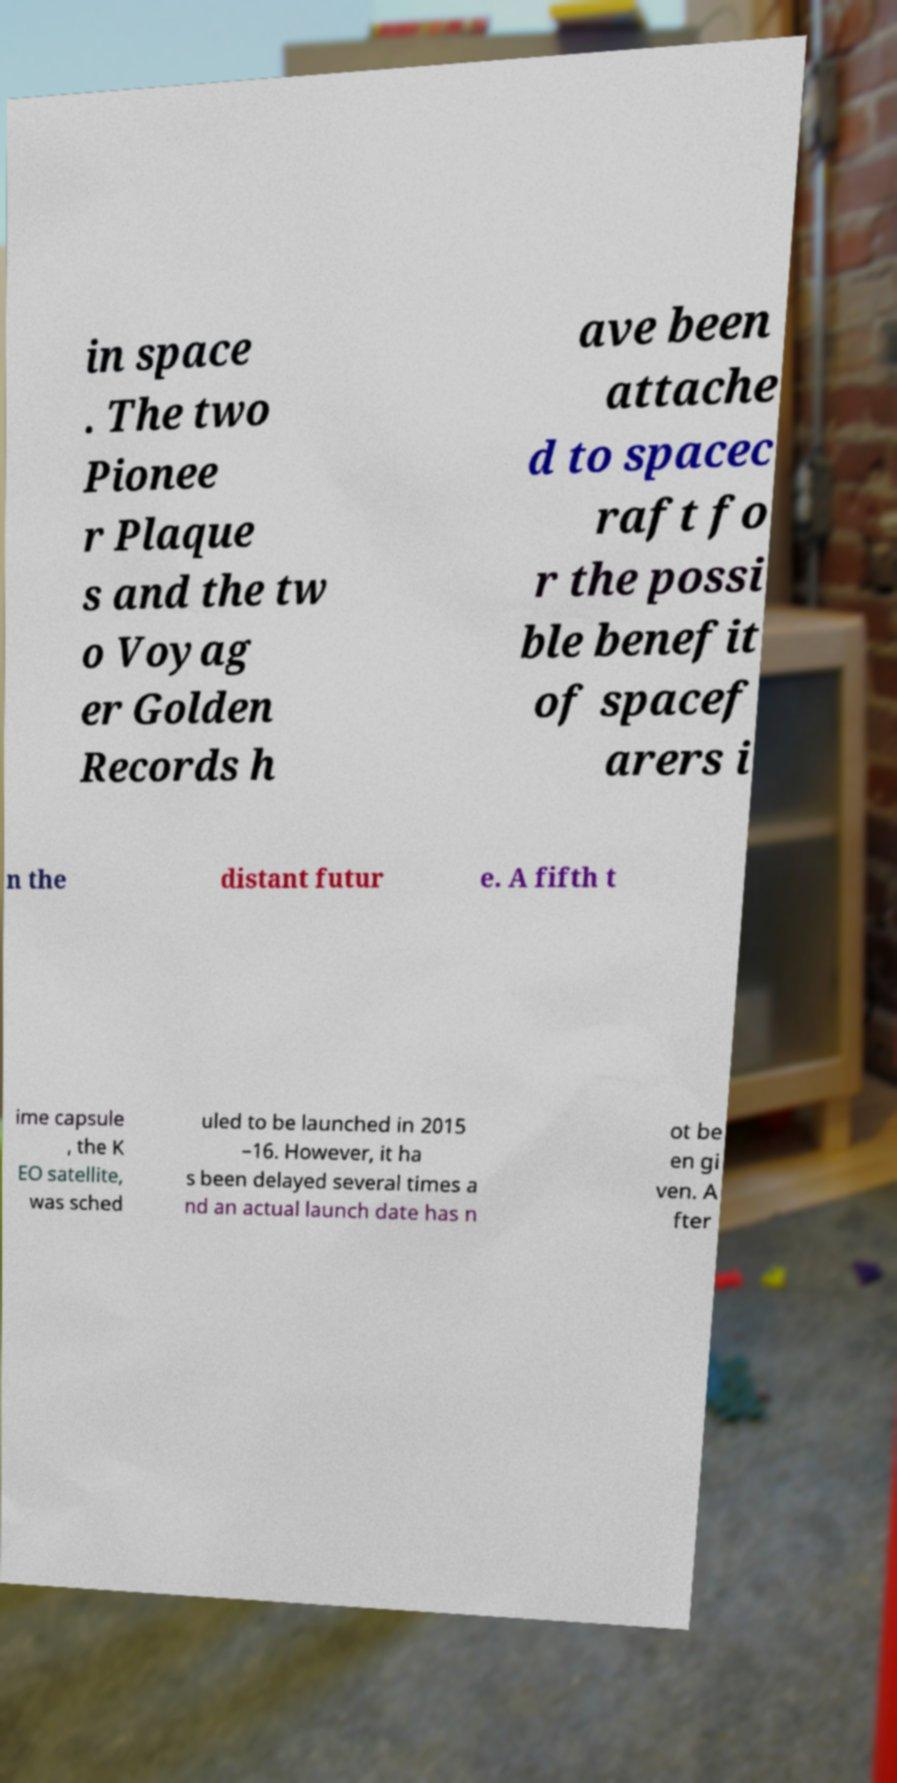Could you extract and type out the text from this image? in space . The two Pionee r Plaque s and the tw o Voyag er Golden Records h ave been attache d to spacec raft fo r the possi ble benefit of spacef arers i n the distant futur e. A fifth t ime capsule , the K EO satellite, was sched uled to be launched in 2015 –16. However, it ha s been delayed several times a nd an actual launch date has n ot be en gi ven. A fter 